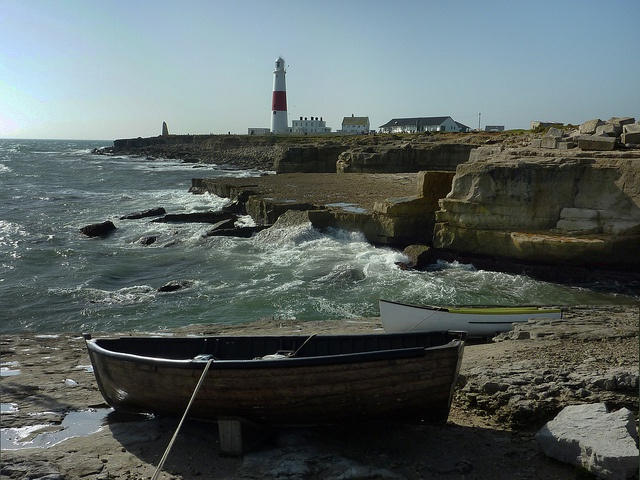Describe the objects in this image and their specific colors. I can see boat in lightblue, black, gray, and darkgray tones and boat in lightblue, gray, black, darkgreen, and purple tones in this image. 